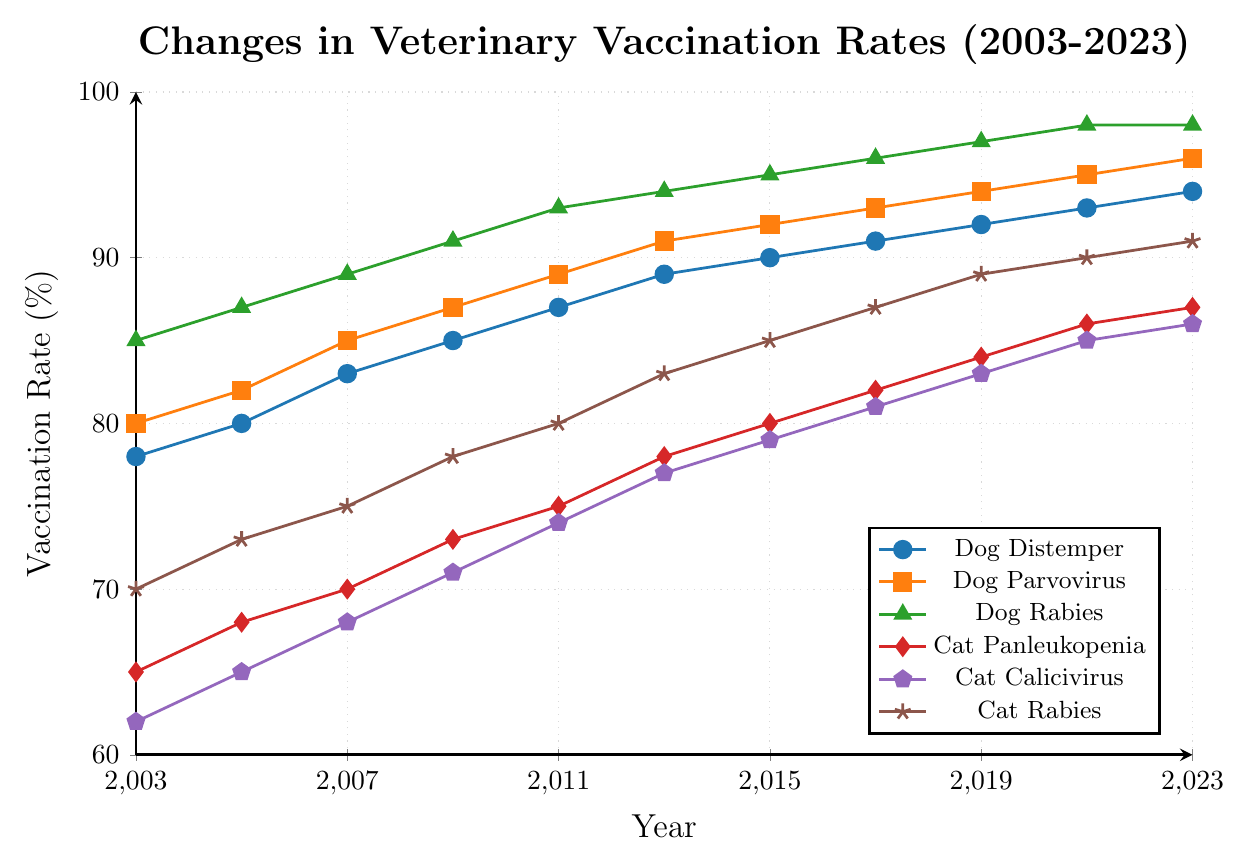What is the general trend in vaccination rates for Dog Distemper from 2003 to 2023? To observe the general trend in Dog Distemper vaccination rates, look at the data points for Dog Distemper from 2003 to 2023. The values consistently increase from 78% in 2003 to 94% in 2023.
Answer: Increasing Which year shows the highest vaccination rate for Cat Rabies, and what is the rate? Scan the data points for Cat Rabies from 2003 to 2023. The highest rate is visible at 91% in 2023.
Answer: 2023, 91% What is the difference between the vaccination rates of Dog Parvovirus and Cat Calicivirus in 2011? In 2011, the vaccination rate for Dog Parvovirus is 89% and for Cat Calicivirus is 74%. Subtract the smaller value from the larger one: 89% - 74% = 15%.
Answer: 15% Which type of vaccine shows the most significant increase in vaccination rates from 2003 to 2023, and what is the increase? For each vaccine type, find the difference between 2023 and 2003 values. Dog Distemper: 94%-78%=16%, Dog Parvovirus: 96%-80%=16%, Dog Rabies: 98%-85%=13%, Cat Panleukopenia: 87%-65%=22%, Cat Calicivirus: 86%-62%=24%, Cat Rabies: 91%-70%=21%. The largest increase is for Cat Calicivirus (24%).
Answer: Cat Calicivirus, 24% In which year did the Cat Calicivirus vaccination rate equal the Dog Distemper vaccination rate of 2007? The Dog Distemper vaccination rate in 2007 is 83%. By examining the data points, we see that the Cat Calicivirus vaccination rate reaches 83% in 2019.
Answer: 2019 What is the average vaccination rate for Dog Rabies across all the years shown in the figure? To find the average, sum up the Dog Rabies vaccination rates for all the years: 85+87+89+91+93+94+95+96+97+98+98 = 1013. Then, divide by the number of years (11): 1013 / 11 ≈ 92.09%.
Answer: 92.09% Between 2005 and 2015, which vaccine shows the highest increase in vaccination rates and by how much? Compare the differences for each vaccine from 2005 to 2015. Dog Distemper: 90%-80%=10%, Dog Parvovirus: 92%-82%=10%, Dog Rabies: 95%-87%=8%, Cat Panleukopenia: 80%-68%=12%, Cat Calicivirus: 79%-65%=14%, Cat Rabies: 85%-73%=12%. The highest increase is shown by Cat Calicivirus (14%).
Answer: Cat Calicivirus, 14% Which vaccine had the lowest vaccination rate in 2009, and what was the rate? Check the data points for 2009 and identify the lowest value. Cat Calicivirus has the lowest rate at 71%.
Answer: Cat Calicivirus, 71% How do the vaccination rates for Cat Rabies and Dog Rabies in 2021 compare? In 2021, the Cat Rabies vaccination rate is 90% and the Dog Rabies vaccination rate is 98%. Dog Rabies has a higher rate compared to Cat Rabies by 8%.
Answer: Dog Rabies is higher by 8% What was the combined vaccination rate for Dog Distemper and Cat Panleukopenia in 2013? Add the rates for Dog Distemper (89%) and Cat Panleukopenia (78%) in 2013. 89% + 78% = 167%.
Answer: 167% 